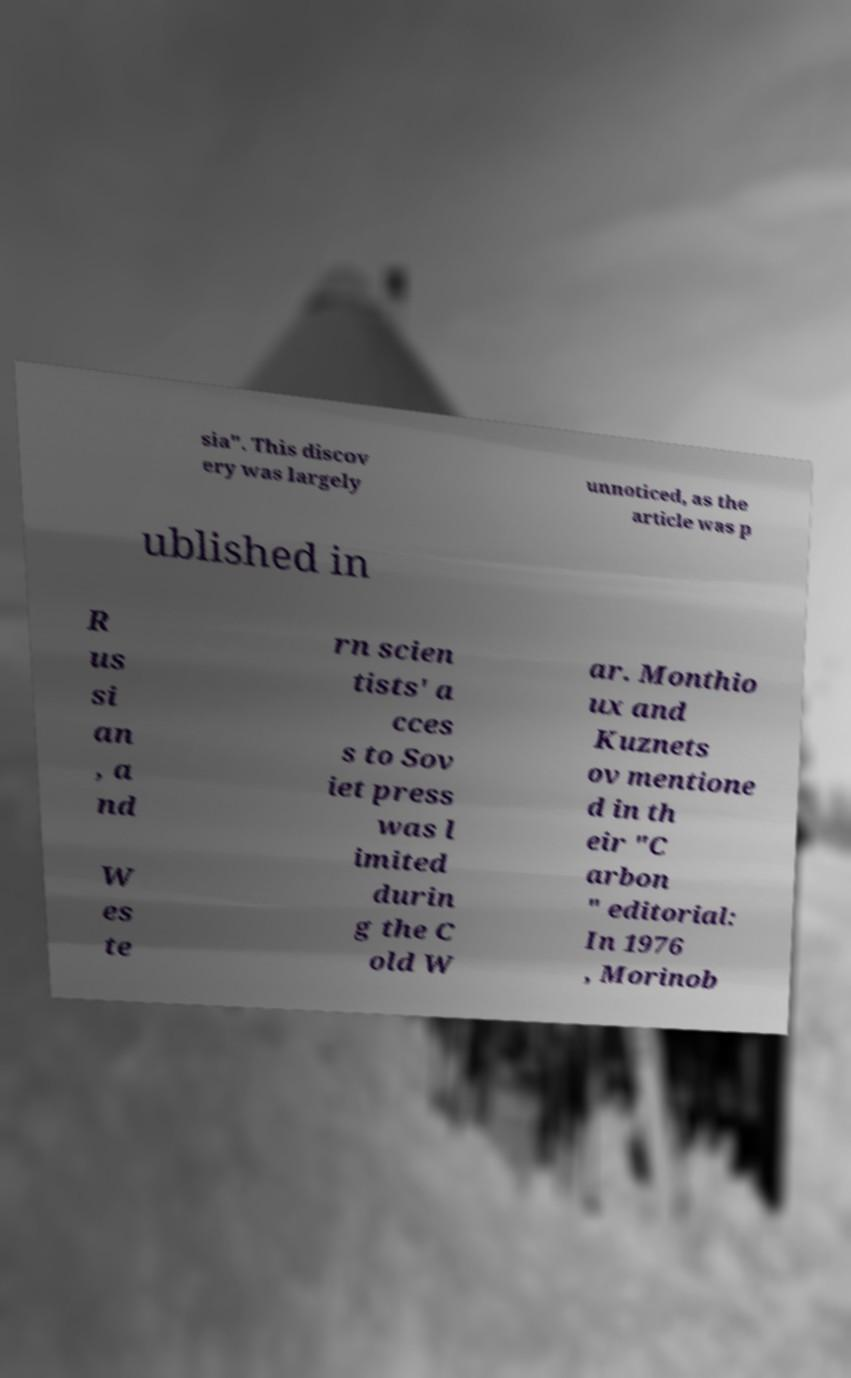Please read and relay the text visible in this image. What does it say? sia". This discov ery was largely unnoticed, as the article was p ublished in R us si an , a nd W es te rn scien tists' a cces s to Sov iet press was l imited durin g the C old W ar. Monthio ux and Kuznets ov mentione d in th eir "C arbon " editorial: In 1976 , Morinob 